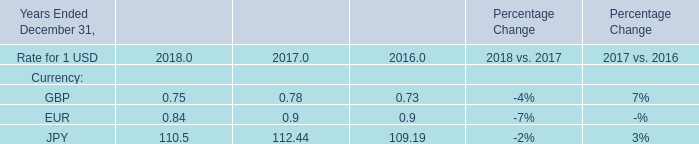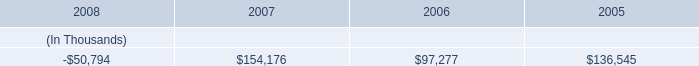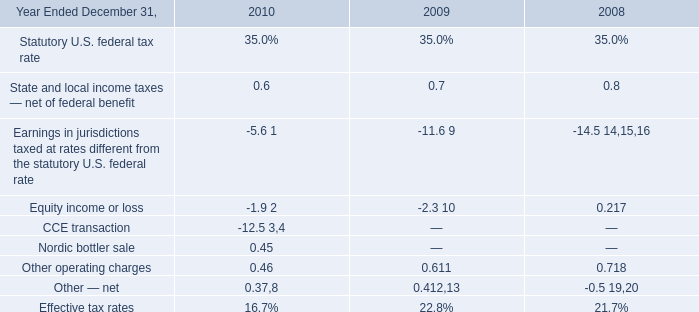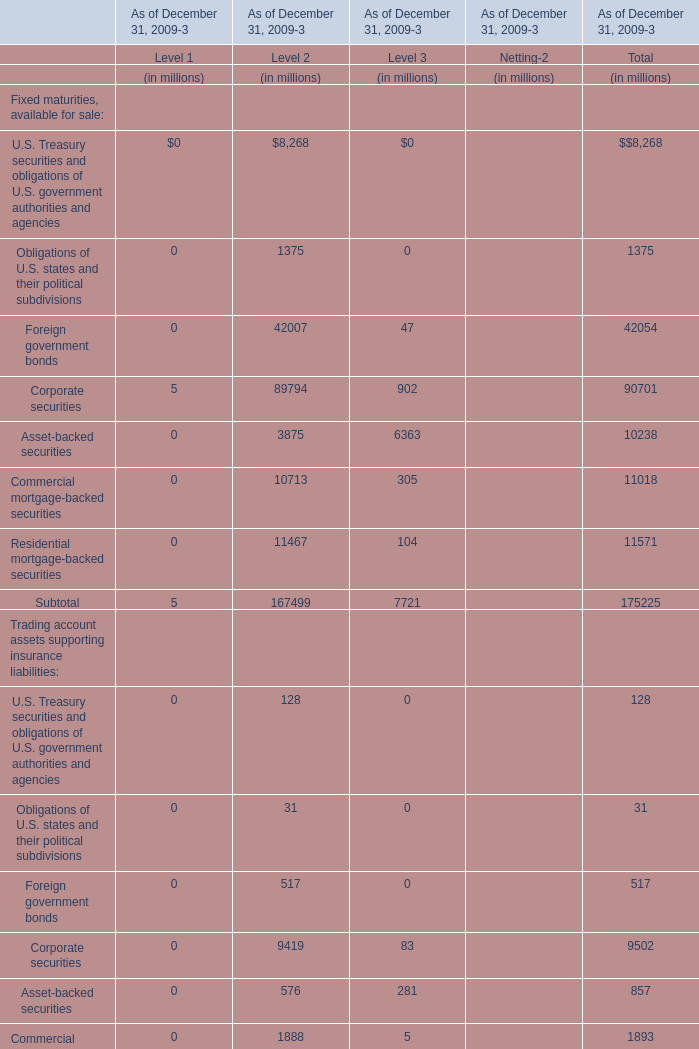what is the annual expense for entergy texas incurred from the series mortgage bonds due february 2019 , in millions? 
Computations: (500 * 7.125%)
Answer: 35.625. 